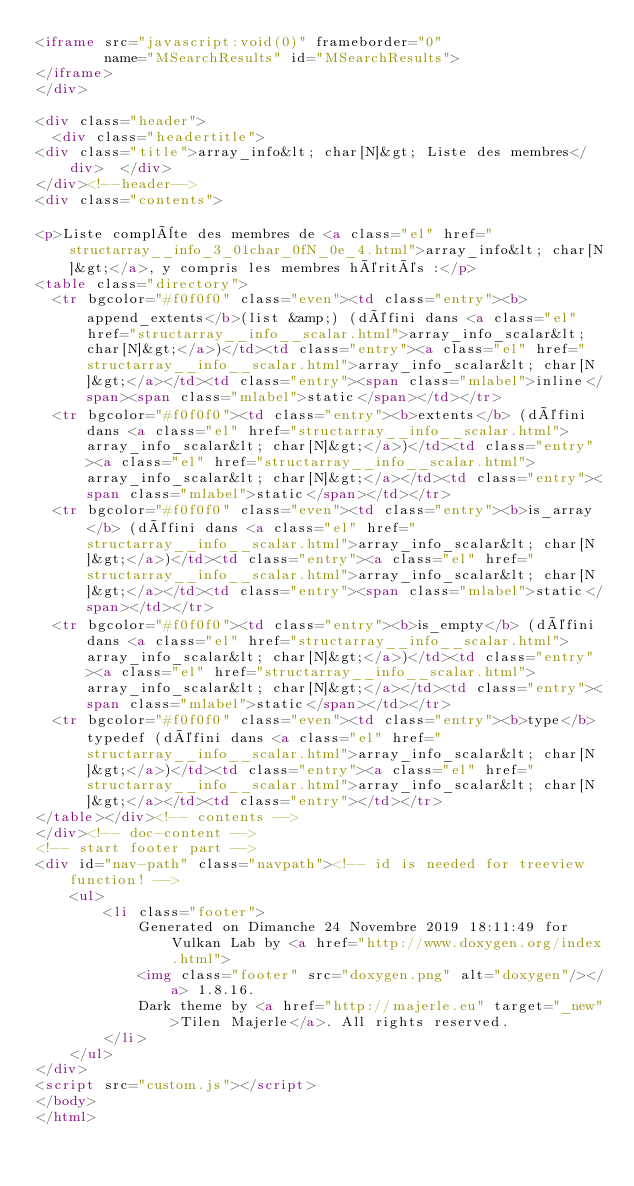<code> <loc_0><loc_0><loc_500><loc_500><_HTML_><iframe src="javascript:void(0)" frameborder="0" 
        name="MSearchResults" id="MSearchResults">
</iframe>
</div>

<div class="header">
  <div class="headertitle">
<div class="title">array_info&lt; char[N]&gt; Liste des membres</div>  </div>
</div><!--header-->
<div class="contents">

<p>Liste complète des membres de <a class="el" href="structarray__info_3_01char_0fN_0e_4.html">array_info&lt; char[N]&gt;</a>, y compris les membres hérités :</p>
<table class="directory">
  <tr bgcolor="#f0f0f0" class="even"><td class="entry"><b>append_extents</b>(list &amp;) (défini dans <a class="el" href="structarray__info__scalar.html">array_info_scalar&lt; char[N]&gt;</a>)</td><td class="entry"><a class="el" href="structarray__info__scalar.html">array_info_scalar&lt; char[N]&gt;</a></td><td class="entry"><span class="mlabel">inline</span><span class="mlabel">static</span></td></tr>
  <tr bgcolor="#f0f0f0"><td class="entry"><b>extents</b> (défini dans <a class="el" href="structarray__info__scalar.html">array_info_scalar&lt; char[N]&gt;</a>)</td><td class="entry"><a class="el" href="structarray__info__scalar.html">array_info_scalar&lt; char[N]&gt;</a></td><td class="entry"><span class="mlabel">static</span></td></tr>
  <tr bgcolor="#f0f0f0" class="even"><td class="entry"><b>is_array</b> (défini dans <a class="el" href="structarray__info__scalar.html">array_info_scalar&lt; char[N]&gt;</a>)</td><td class="entry"><a class="el" href="structarray__info__scalar.html">array_info_scalar&lt; char[N]&gt;</a></td><td class="entry"><span class="mlabel">static</span></td></tr>
  <tr bgcolor="#f0f0f0"><td class="entry"><b>is_empty</b> (défini dans <a class="el" href="structarray__info__scalar.html">array_info_scalar&lt; char[N]&gt;</a>)</td><td class="entry"><a class="el" href="structarray__info__scalar.html">array_info_scalar&lt; char[N]&gt;</a></td><td class="entry"><span class="mlabel">static</span></td></tr>
  <tr bgcolor="#f0f0f0" class="even"><td class="entry"><b>type</b> typedef (défini dans <a class="el" href="structarray__info__scalar.html">array_info_scalar&lt; char[N]&gt;</a>)</td><td class="entry"><a class="el" href="structarray__info__scalar.html">array_info_scalar&lt; char[N]&gt;</a></td><td class="entry"></td></tr>
</table></div><!-- contents -->
</div><!-- doc-content -->
<!-- start footer part -->
<div id="nav-path" class="navpath"><!-- id is needed for treeview function! -->
    <ul>
        <li class="footer">
            Generated on Dimanche 24 Novembre 2019 18:11:49 for Vulkan Lab by <a href="http://www.doxygen.org/index.html">
            <img class="footer" src="doxygen.png" alt="doxygen"/></a> 1.8.16.
            Dark theme by <a href="http://majerle.eu" target="_new">Tilen Majerle</a>. All rights reserved.
        </li>
    </ul>
</div>
<script src="custom.js"></script>
</body>
</html></code> 